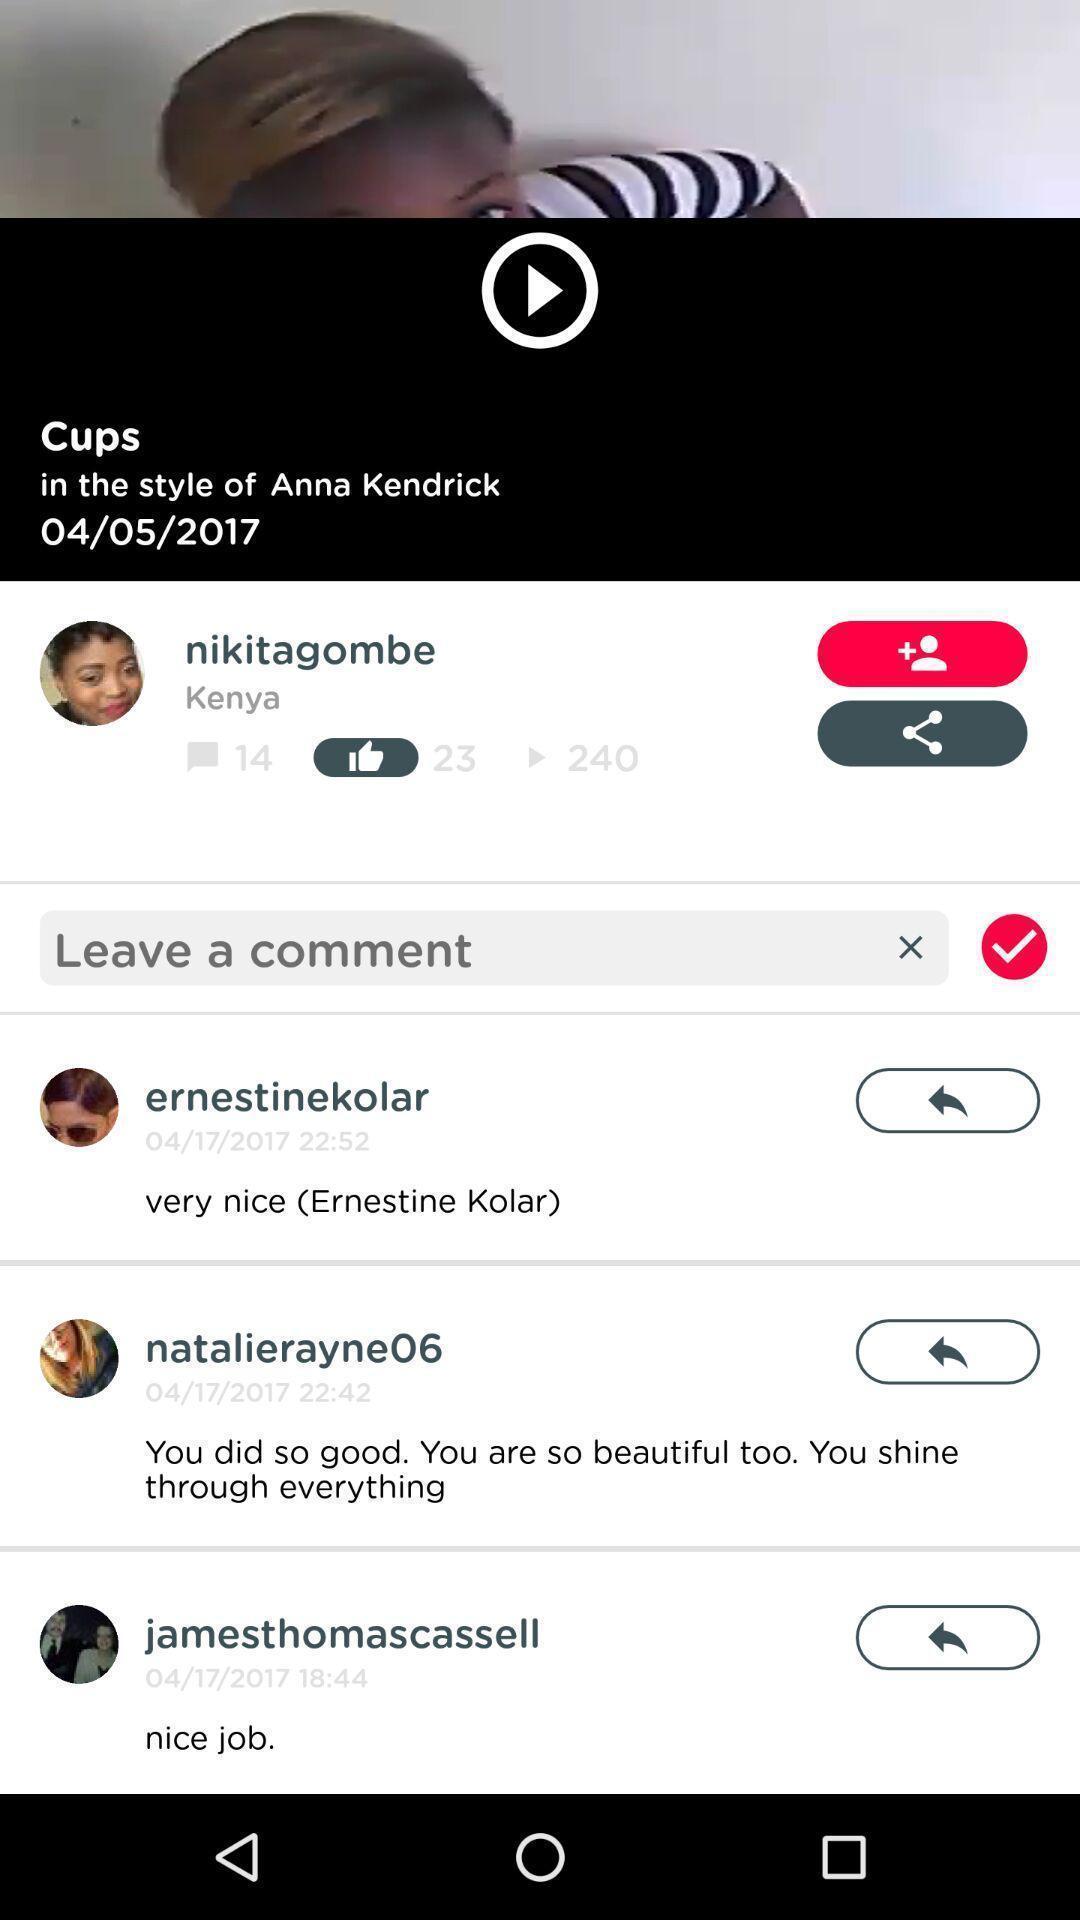Explain what's happening in this screen capture. Page that displaying video comments. 